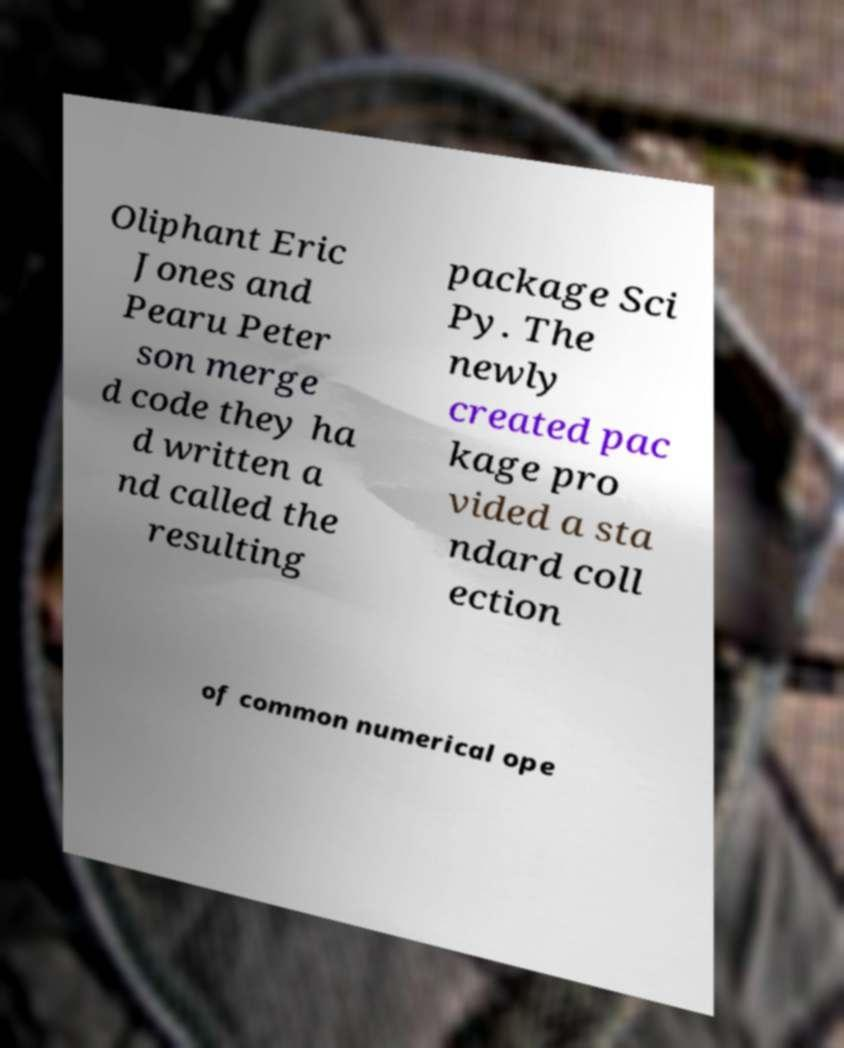Could you extract and type out the text from this image? Oliphant Eric Jones and Pearu Peter son merge d code they ha d written a nd called the resulting package Sci Py. The newly created pac kage pro vided a sta ndard coll ection of common numerical ope 